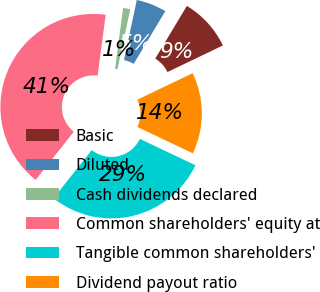Convert chart to OTSL. <chart><loc_0><loc_0><loc_500><loc_500><pie_chart><fcel>Basic<fcel>Diluted<fcel>Cash dividends declared<fcel>Common shareholders' equity at<fcel>Tangible common shareholders'<fcel>Dividend payout ratio<nl><fcel>9.28%<fcel>5.26%<fcel>1.24%<fcel>41.43%<fcel>28.61%<fcel>14.18%<nl></chart> 